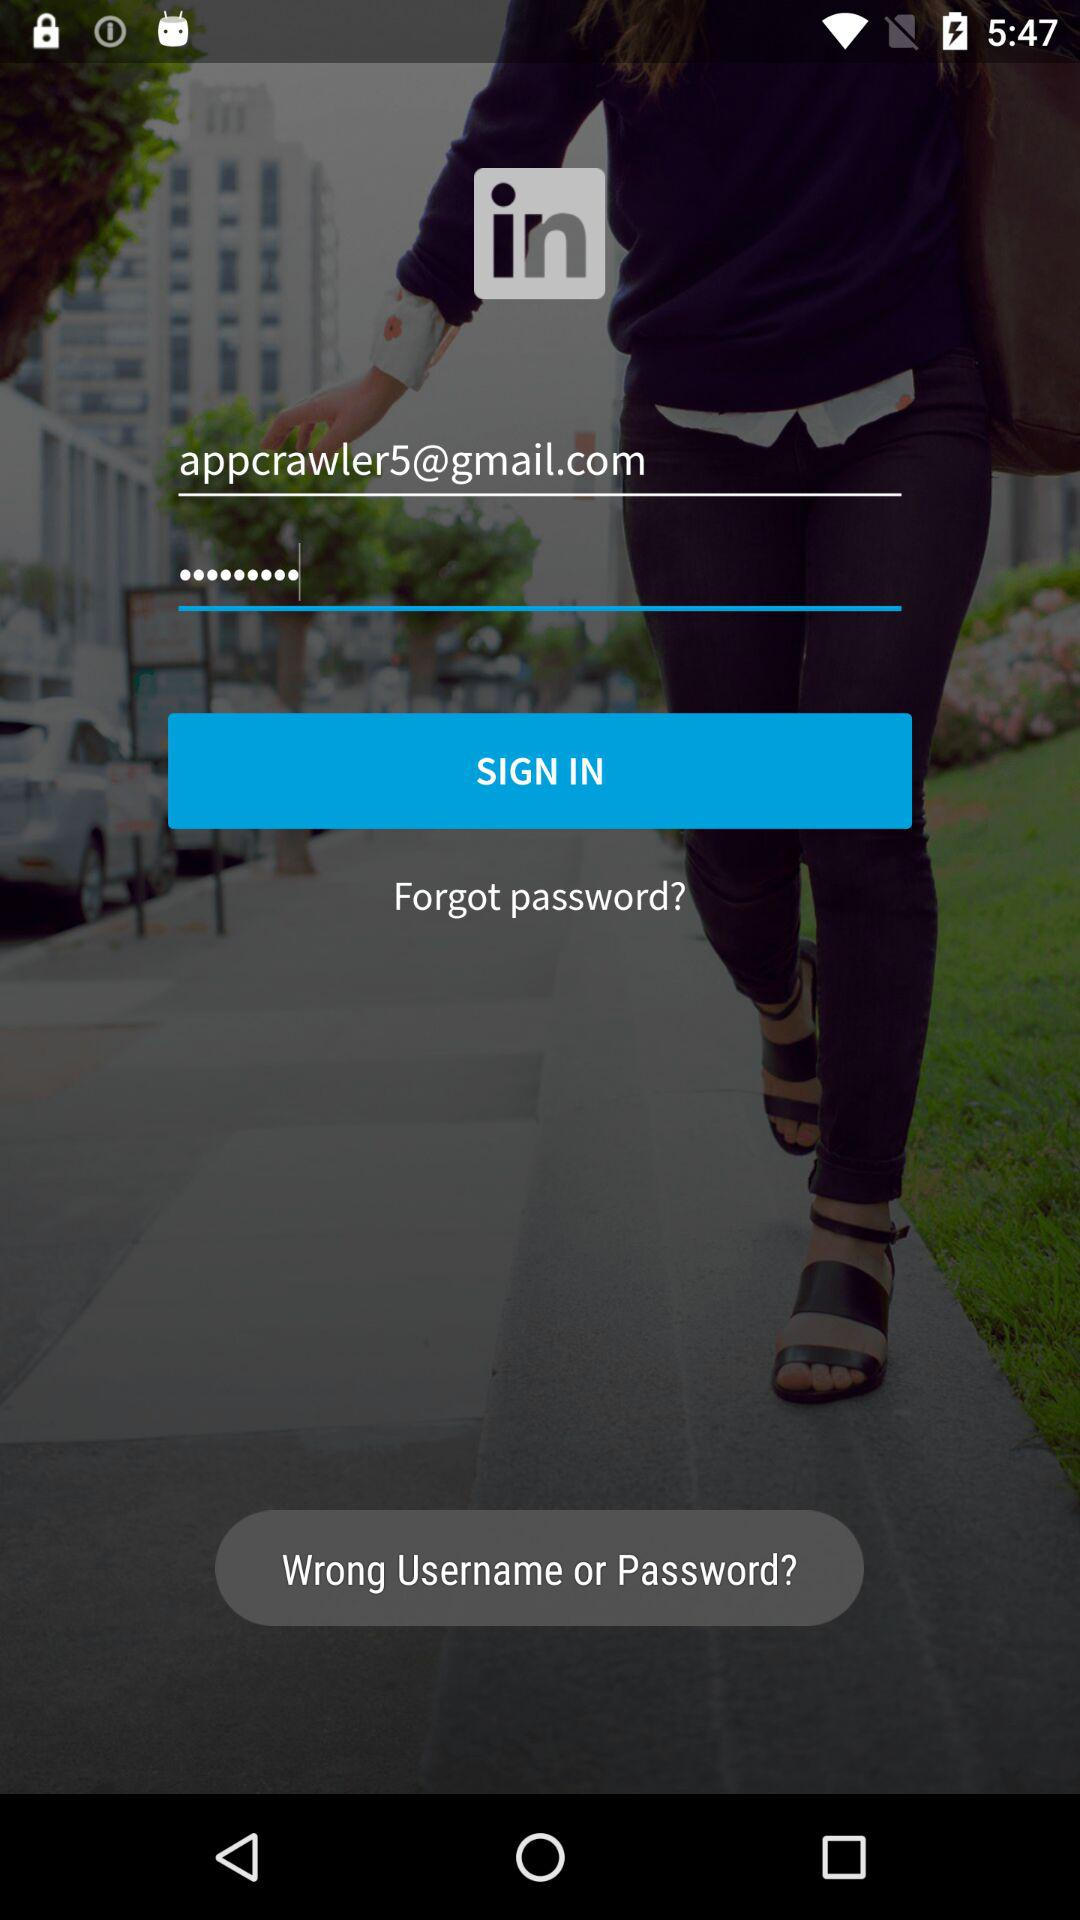What Gmail address is used to sign in? The used Gmail address is appcrawler5@gmail.com. 